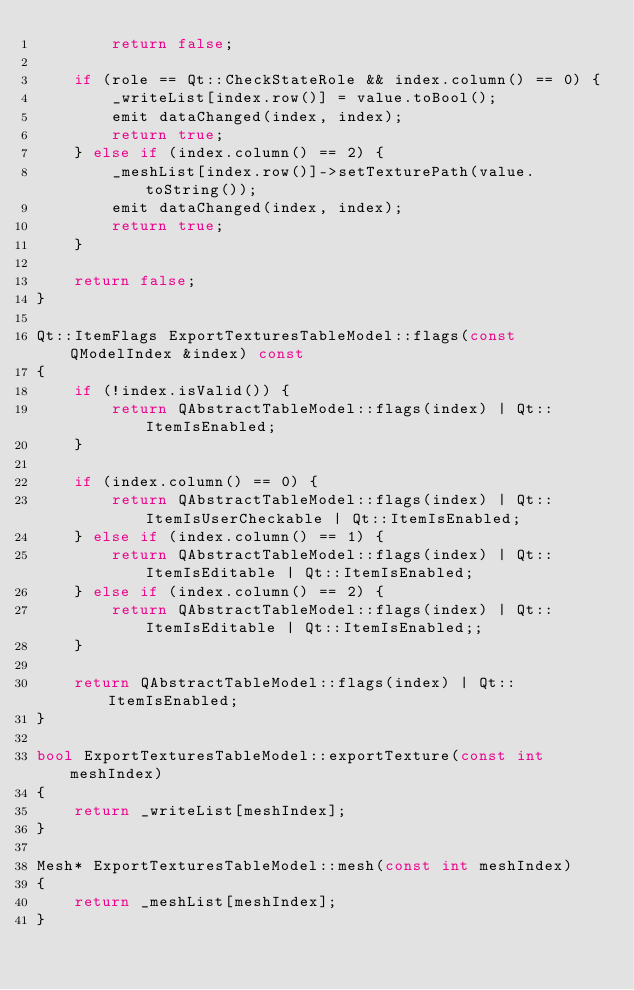<code> <loc_0><loc_0><loc_500><loc_500><_C++_>        return false;

    if (role == Qt::CheckStateRole && index.column() == 0) {
        _writeList[index.row()] = value.toBool();
        emit dataChanged(index, index);
        return true;
    } else if (index.column() == 2) {
        _meshList[index.row()]->setTexturePath(value.toString());
        emit dataChanged(index, index);
        return true;
    }

    return false;
}

Qt::ItemFlags ExportTexturesTableModel::flags(const QModelIndex &index) const
{
    if (!index.isValid()) {
        return QAbstractTableModel::flags(index) | Qt::ItemIsEnabled;
    }

    if (index.column() == 0) {
        return QAbstractTableModel::flags(index) | Qt::ItemIsUserCheckable | Qt::ItemIsEnabled;
    } else if (index.column() == 1) {
        return QAbstractTableModel::flags(index) | Qt::ItemIsEditable | Qt::ItemIsEnabled;
    } else if (index.column() == 2) {
        return QAbstractTableModel::flags(index) | Qt::ItemIsEditable | Qt::ItemIsEnabled;;
    }

    return QAbstractTableModel::flags(index) | Qt::ItemIsEnabled;
}

bool ExportTexturesTableModel::exportTexture(const int meshIndex)
{
    return _writeList[meshIndex];
}

Mesh* ExportTexturesTableModel::mesh(const int meshIndex)
{
    return _meshList[meshIndex];
}
</code> 